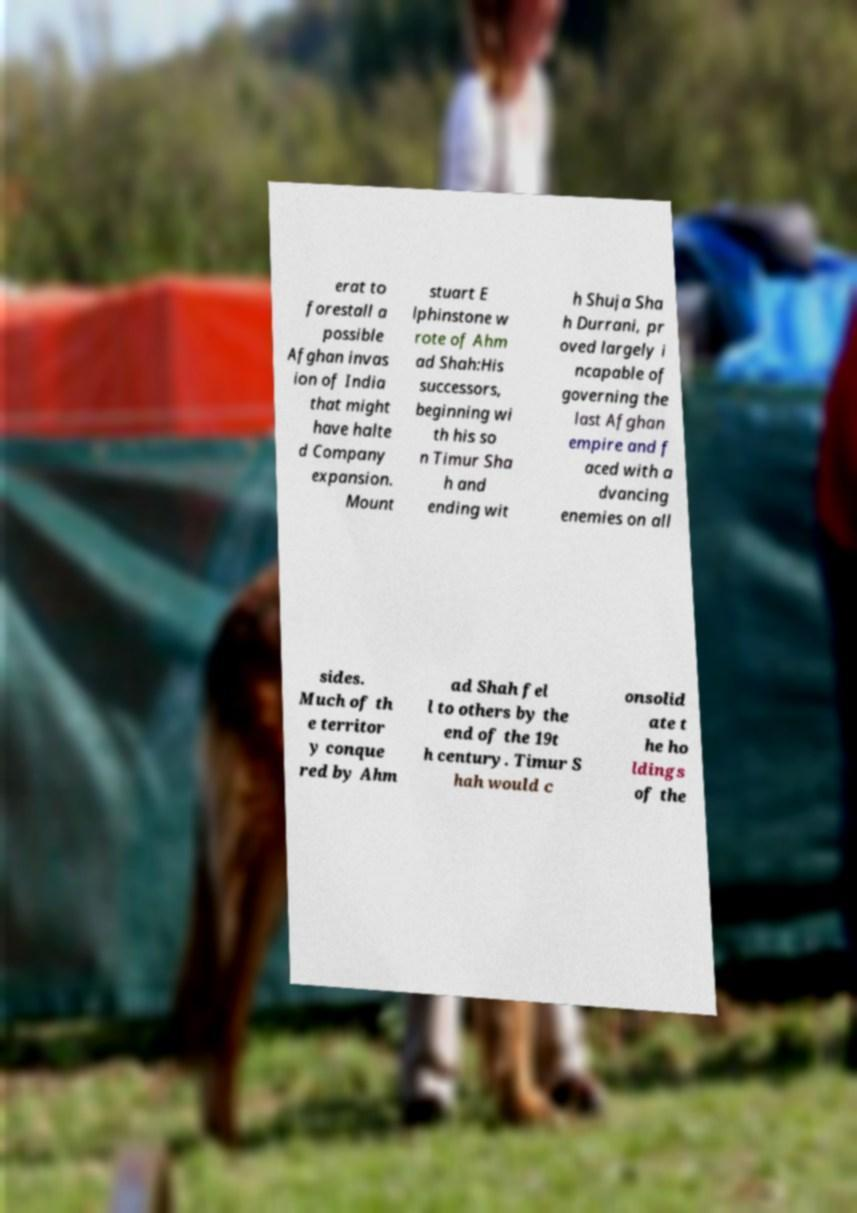I need the written content from this picture converted into text. Can you do that? erat to forestall a possible Afghan invas ion of India that might have halte d Company expansion. Mount stuart E lphinstone w rote of Ahm ad Shah:His successors, beginning wi th his so n Timur Sha h and ending wit h Shuja Sha h Durrani, pr oved largely i ncapable of governing the last Afghan empire and f aced with a dvancing enemies on all sides. Much of th e territor y conque red by Ahm ad Shah fel l to others by the end of the 19t h century. Timur S hah would c onsolid ate t he ho ldings of the 